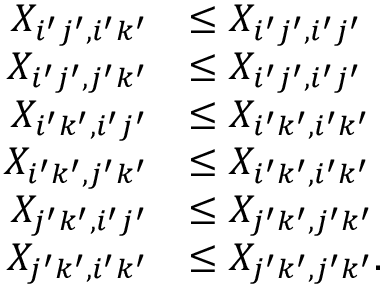Convert formula to latex. <formula><loc_0><loc_0><loc_500><loc_500>\begin{array} { r l } { X _ { i ^ { \prime } j ^ { \prime } , i ^ { \prime } k ^ { \prime } } } & { \leq X _ { i ^ { \prime } j ^ { \prime } , i ^ { \prime } j ^ { \prime } } } \\ { X _ { i ^ { \prime } j ^ { \prime } , j ^ { \prime } k ^ { \prime } } } & { \leq X _ { i ^ { \prime } j ^ { \prime } , i ^ { \prime } j ^ { \prime } } } \\ { X _ { i ^ { \prime } k ^ { \prime } , i ^ { \prime } j ^ { \prime } } } & { \leq X _ { i ^ { \prime } k ^ { \prime } , i ^ { \prime } k ^ { \prime } } } \\ { X _ { i ^ { \prime } k ^ { \prime } , j ^ { \prime } k ^ { \prime } } } & { \leq X _ { i ^ { \prime } k ^ { \prime } , i ^ { \prime } k ^ { \prime } } } \\ { X _ { j ^ { \prime } k ^ { \prime } , i ^ { \prime } j ^ { \prime } } } & { \leq X _ { j ^ { \prime } k ^ { \prime } , j ^ { \prime } k ^ { \prime } } } \\ { X _ { j ^ { \prime } k ^ { \prime } , i ^ { \prime } k ^ { \prime } } } & { \leq X _ { j ^ { \prime } k ^ { \prime } , j ^ { \prime } k ^ { \prime } } . } \end{array}</formula> 